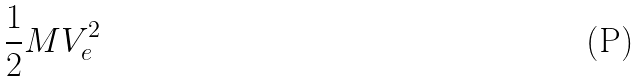Convert formula to latex. <formula><loc_0><loc_0><loc_500><loc_500>\frac { 1 } { 2 } M V _ { e } ^ { 2 }</formula> 